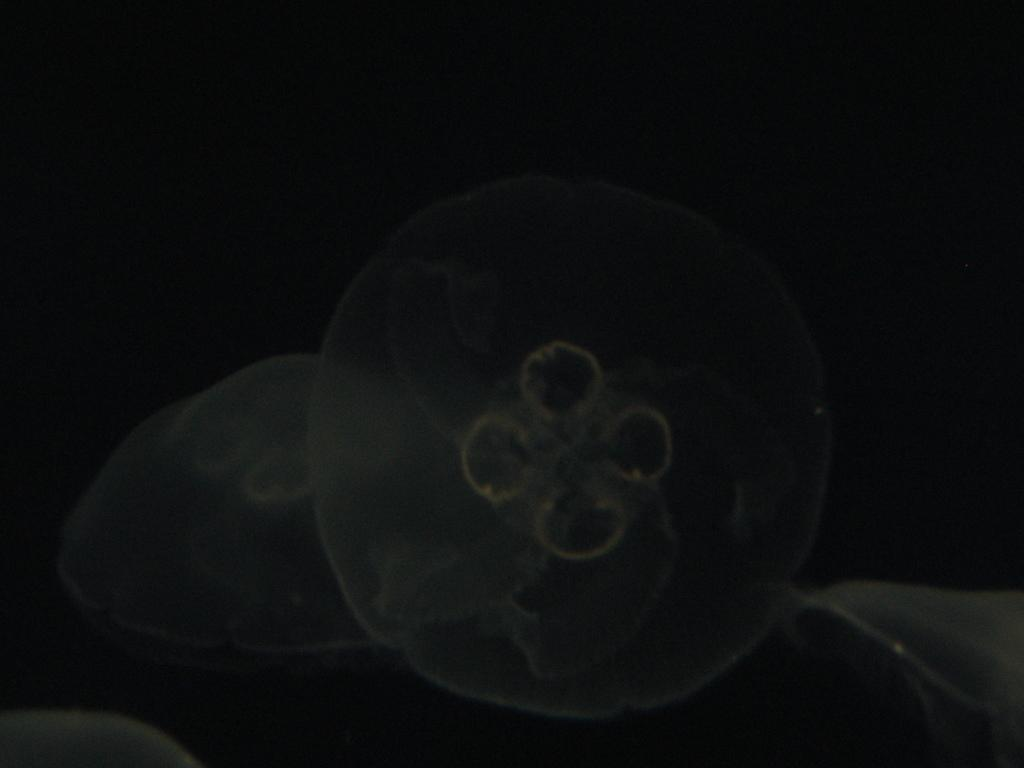What is the main subject of the image? Unfortunately, there are no specific details provided about the image, so it is impossible to determine the main subject. How many chickens are present in the image? There is no information provided about the image, so it is impossible to determine if any chickens are present. What type of dress is the person wearing in the image? There is no information provided about the image, so it is impossible to determine if there is a person wearing a dress. What type of vacation destination is depicted in the image? There is no information provided about the image, so it is impossible to determine if any vacation destination is depicted. 